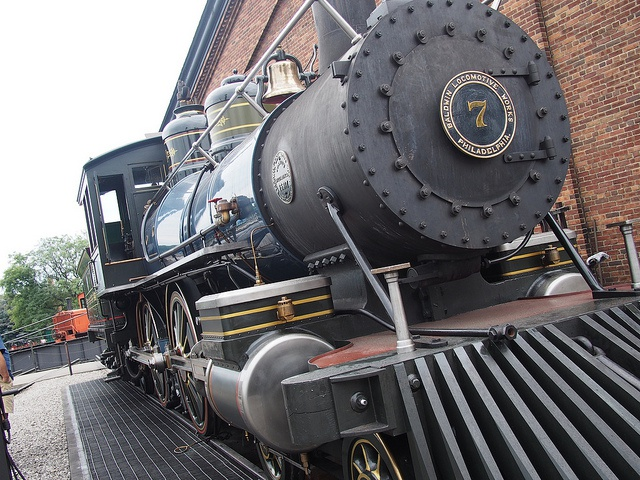Describe the objects in this image and their specific colors. I can see train in white, black, gray, darkgray, and lightgray tones and train in white, salmon, brown, and black tones in this image. 